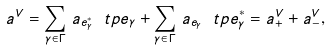<formula> <loc_0><loc_0><loc_500><loc_500>a ^ { V } = \sum _ { \gamma \in \Gamma } \, a _ { e ^ { * } _ { \gamma } } \ t p e _ { \gamma } + \sum _ { \gamma \in \Gamma } \, a _ { e _ { \gamma } } \ t p e _ { \gamma } ^ { * } = a ^ { V } _ { + } + a ^ { V } _ { - } ,</formula> 